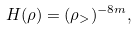<formula> <loc_0><loc_0><loc_500><loc_500>H ( \rho ) = ( \rho _ { > } ) ^ { - 8 m } ,</formula> 